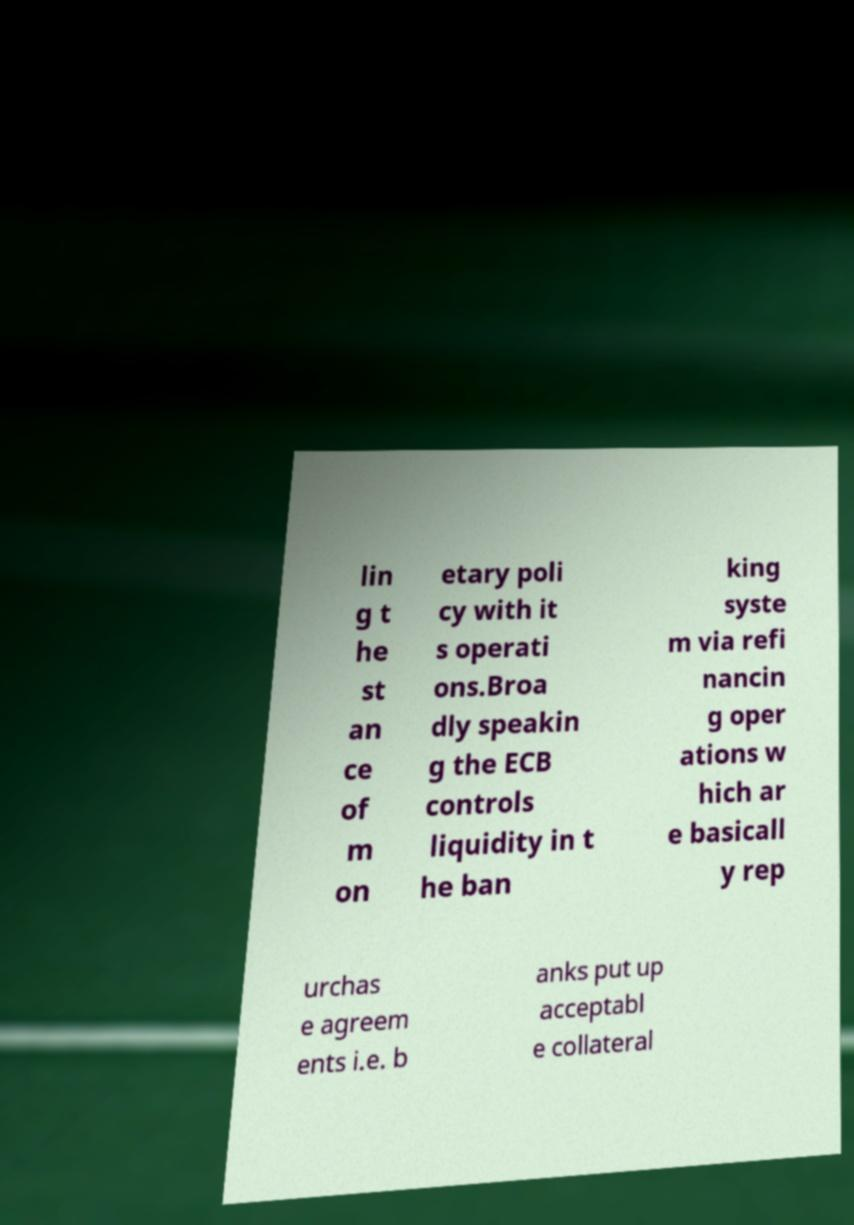Could you extract and type out the text from this image? lin g t he st an ce of m on etary poli cy with it s operati ons.Broa dly speakin g the ECB controls liquidity in t he ban king syste m via refi nancin g oper ations w hich ar e basicall y rep urchas e agreem ents i.e. b anks put up acceptabl e collateral 